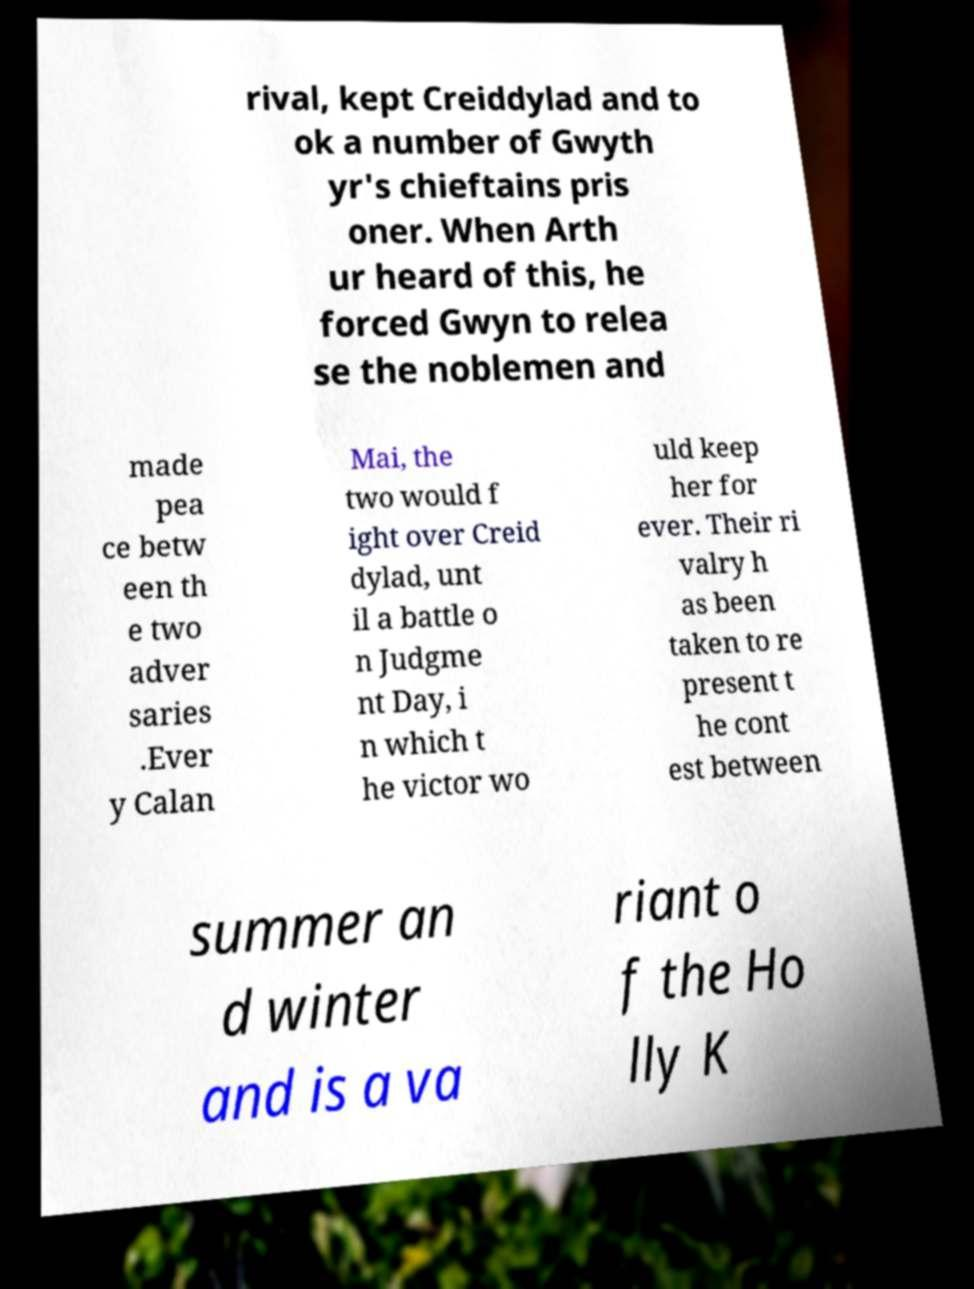I need the written content from this picture converted into text. Can you do that? rival, kept Creiddylad and to ok a number of Gwyth yr's chieftains pris oner. When Arth ur heard of this, he forced Gwyn to relea se the noblemen and made pea ce betw een th e two adver saries .Ever y Calan Mai, the two would f ight over Creid dylad, unt il a battle o n Judgme nt Day, i n which t he victor wo uld keep her for ever. Their ri valry h as been taken to re present t he cont est between summer an d winter and is a va riant o f the Ho lly K 